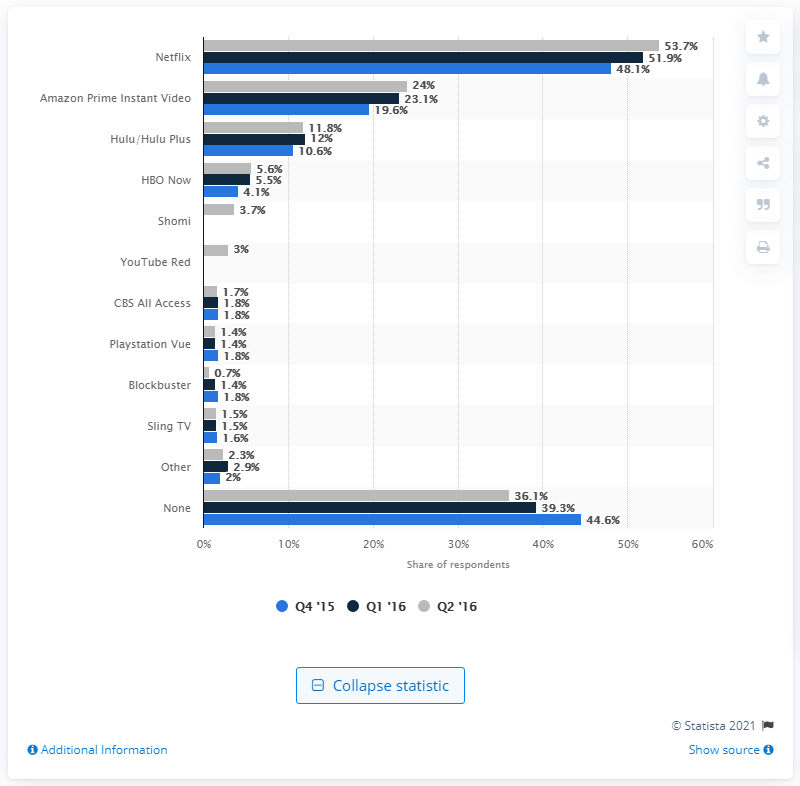Draw attention to some important aspects in this diagram. During the last measured period, 1.5% of respondents used Sling TV. 